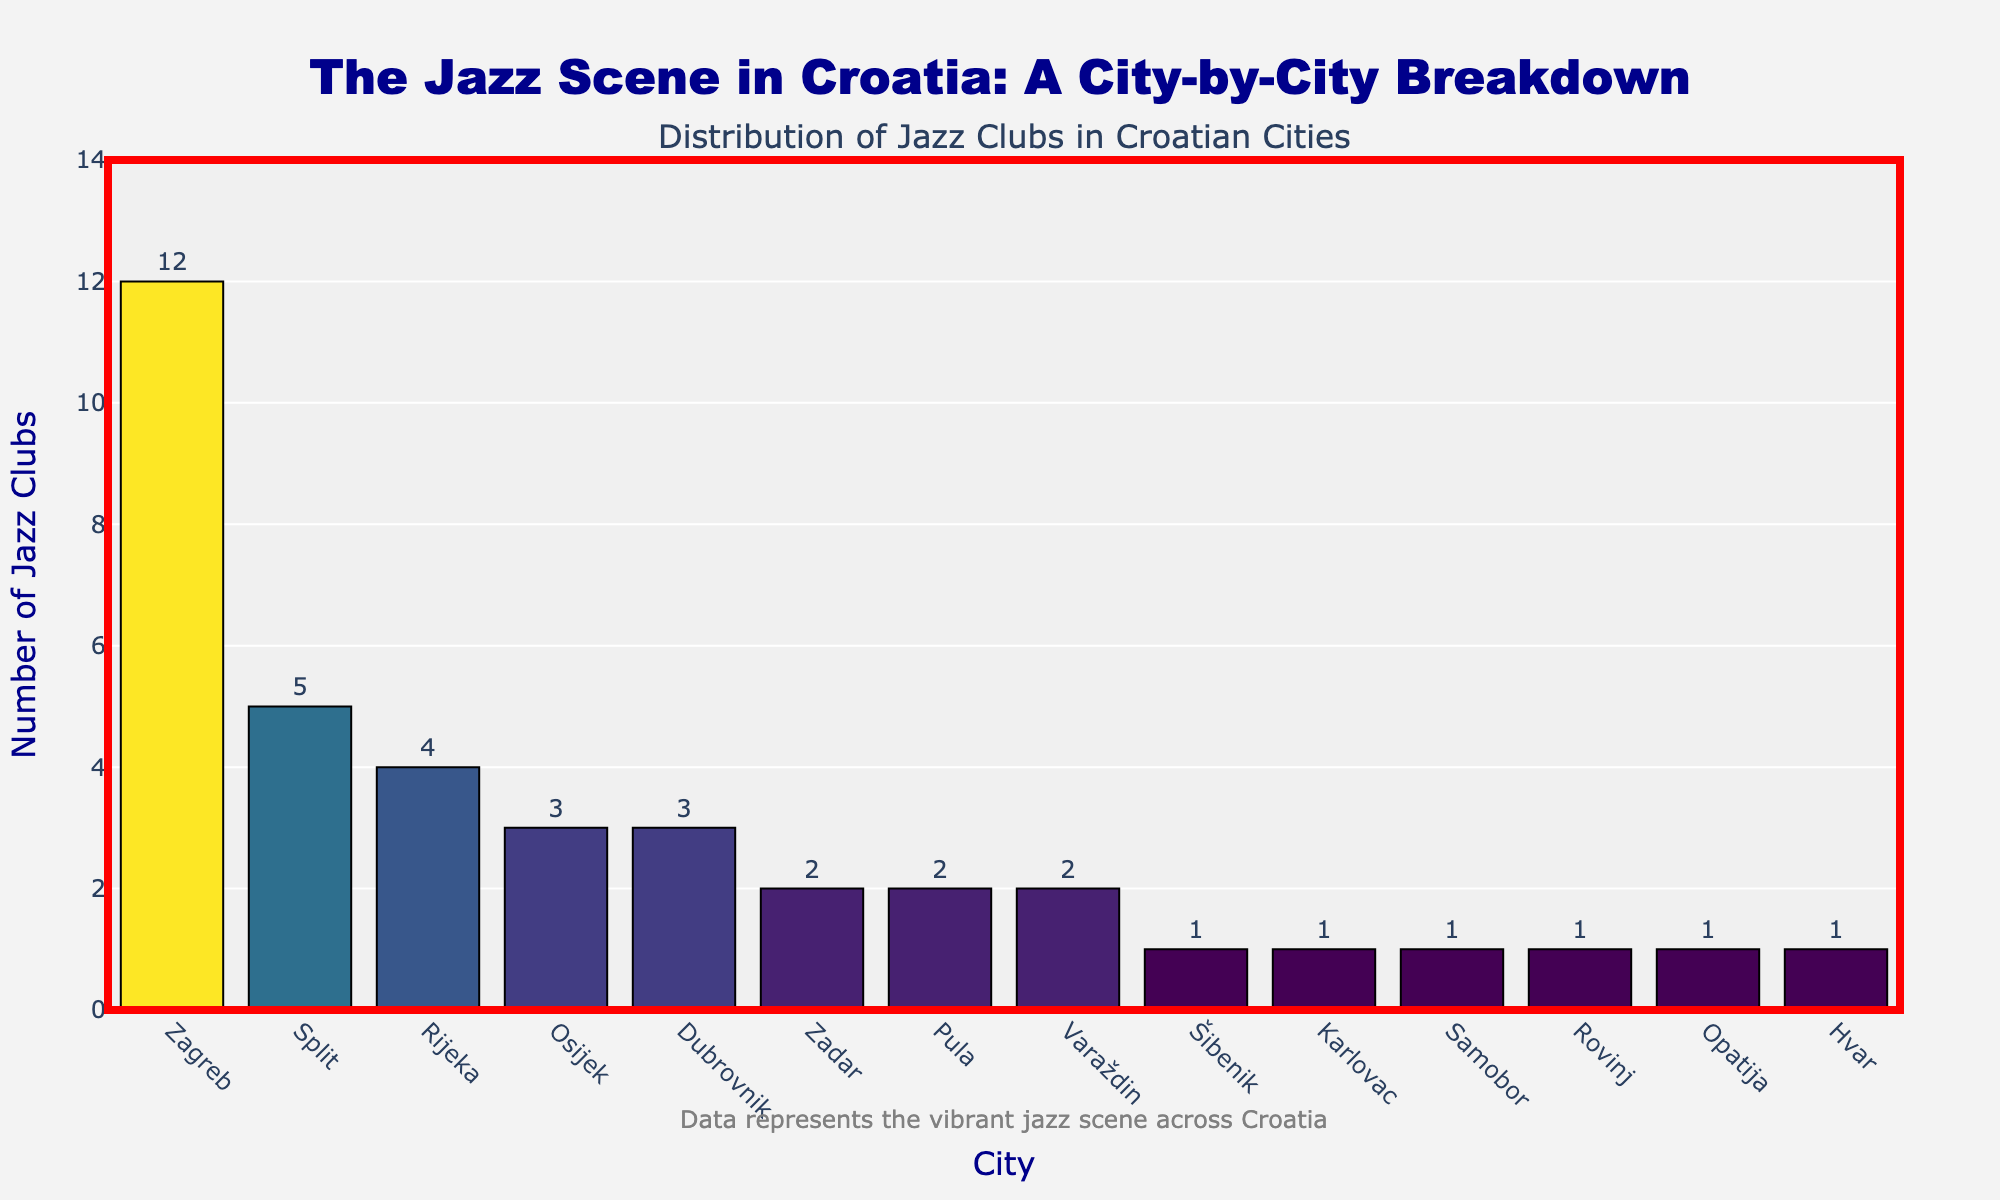Which city has the highest number of jazz clubs? The bar corresponding to Zagreb has the highest height in the bar chart, indicating that Zagreb has the most number of jazz clubs.
Answer: Zagreb How many jazz clubs are there in Osijek and Rijeka combined? The number of jazz clubs in Osijek is 3, and in Rijeka, it is 4. Adding these together gives 3 + 4 = 7.
Answer: 7 How many cities have only one jazz club? The cities with only one jazz club are Šibenik, Karlovac, Samobor, Rovinj, Opatija, and Hvar. Counting these gives 6 cities total.
Answer: 6 Which cities have an equal number of jazz clubs? The cities with the same number of jazz clubs are Osijek and Dubrovnik (3 each), Zadar, Pula, and Varaždin (2 each), and the six cities with 1 each (Šibenik, Karlovac, Samobor, Rovinj, Opatija, Hvar).
Answer: Osijek and Dubrovnik; Zadar, Pula, and Varaždin; Šibenik, Karlovac, Samobor, Rovinj, Opatija, Hvar What's the total number of jazz clubs represented in the chart? By summing the number of jazz clubs in each city: 12 (Zagreb) + 5 (Split) + 4 (Rijeka) + 3 (Osijek) + 3 (Dubrovnik) + 2 (Zadar) + 2 (Pula) + 2 (Varaždin) + 1 (Šibenik) + 1 (Karlovac) + 1 (Samobor) + 1 (Rovinj) + 1 (Opatija) + 1 (Hvar), we get a total of 39.
Answer: 39 Which city has the second-highest number of jazz clubs, and what’s the count? Split has the second-highest number of jazz clubs, with 5.
Answer: Split and 5 How does the number of jazz clubs in Dubrovnik compare to those in Zagreb? Dubrovnik has 3 jazz clubs, while Zagreb has 12. Comparatively, Zagreb has 9 more jazz clubs than Dubrovnik.
Answer: Zagreb has 9 more If the total number of jazz clubs in cities with more than 2 clubs doubled, what would the total be? Cities with more than 2 clubs: Zagreb (12), Split (5), Rijeka (4), Osijek (3), Dubrovnik (3). Total: 12 + 5 + 4 + 3 + 3 = 27. Doubling this gives 54. The total number of jazz clubs remains at 39 for cities with 2 or fewer clubs. Adding these: 54 + (39 - 27) = 54 + 12 = 66.
Answer: 66 Which cities have fewer jazz clubs compared to Pula, and how many total clubs are there in those cities? Pula has 2 jazz clubs. Cities with fewer clubs: Šibenik (1), Karlovac (1), Samobor (1), Rovinj (1), Opatija (1), Hvar (1). Total clubs in these cities: 1+1+1+1+1+1 = 6.
Answer: 6 Are there more jazz clubs in coastal cities or inland cities according to the chart? Coastal cities (Zagreb, Split, Rijeka, Dubrovnik, Zadar, Pula, Šibenik, Rovinj, Opatija, Hvar): 12 + 5 + 4 + 3 + 2 + 2 + 1 + 1 + 1 + 1 = 32. Inland cities (Osijek, Varaždin, Karlovac, Samobor): 3 + 2 + 1 + 1 = 7. Conclusion: More jazz clubs in coastal cities.
Answer: Coastal cities have more 